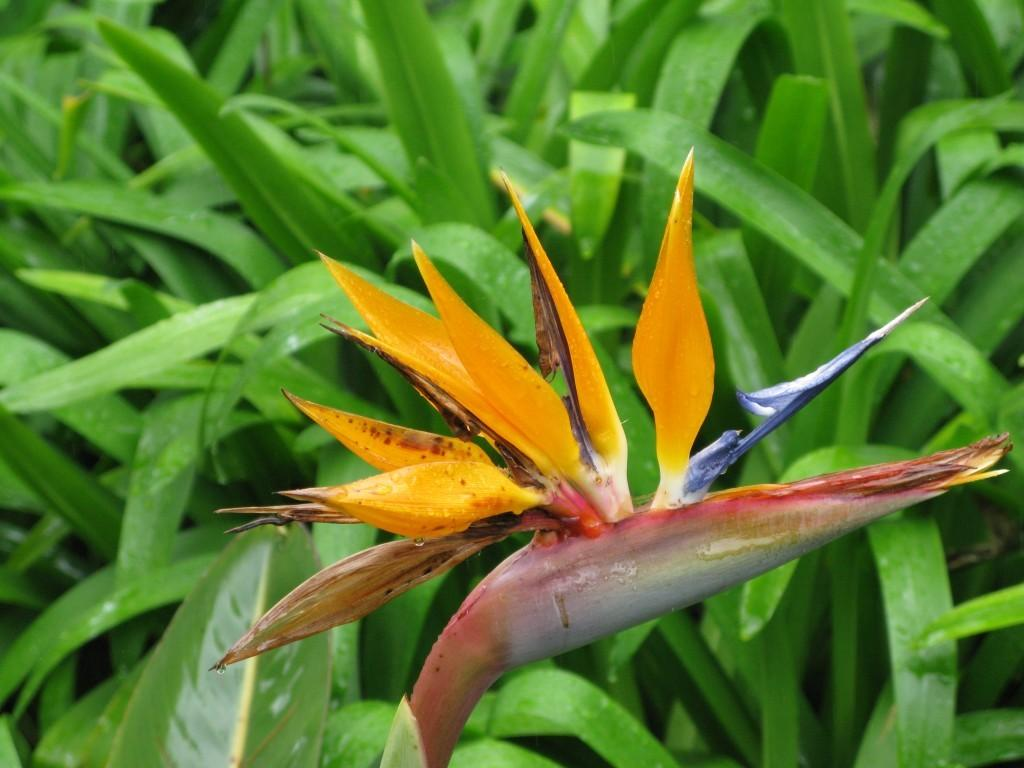What is the main subject of the image? There is a flower in the image. Can you describe the surroundings of the flower? There are plants in the background of the image. How many chickens can be seen near the flower in the image? There are no chickens present in the image. Is there any indication of a wound on the flower in the image? There is no mention of a wound on the flower in the image. Can you describe the behavior of the cat near the flower in the image? There is no cat present in the image. 